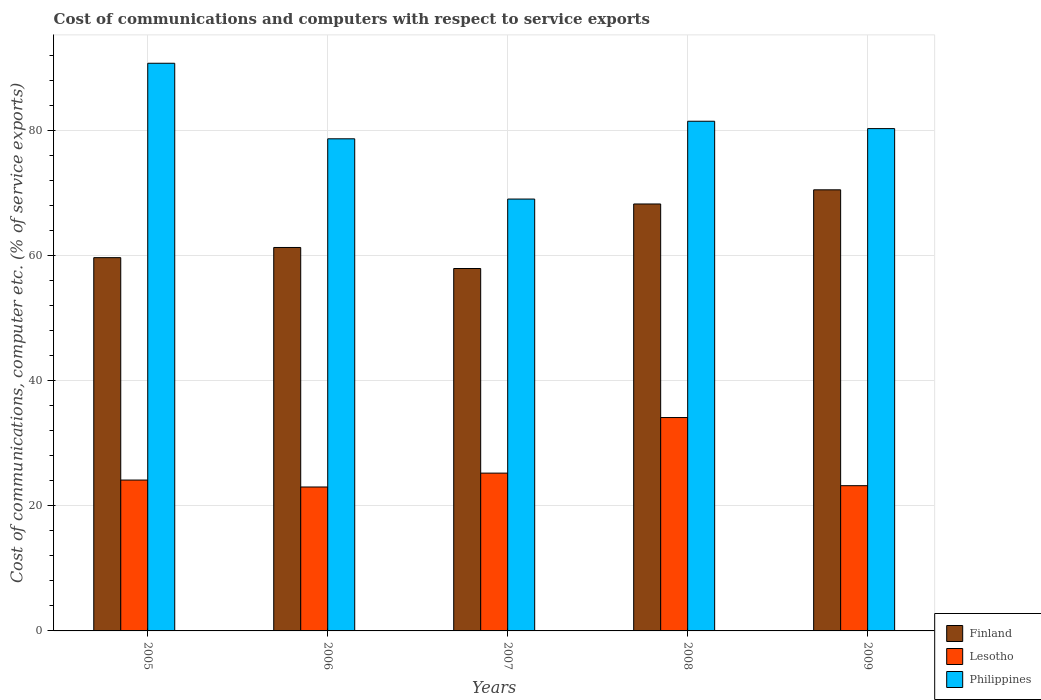Are the number of bars per tick equal to the number of legend labels?
Your answer should be very brief. Yes. What is the cost of communications and computers in Philippines in 2007?
Your answer should be compact. 69.06. Across all years, what is the maximum cost of communications and computers in Lesotho?
Your answer should be compact. 34.12. Across all years, what is the minimum cost of communications and computers in Lesotho?
Offer a very short reply. 23.02. In which year was the cost of communications and computers in Finland maximum?
Keep it short and to the point. 2009. What is the total cost of communications and computers in Lesotho in the graph?
Give a very brief answer. 129.72. What is the difference between the cost of communications and computers in Philippines in 2007 and that in 2008?
Provide a short and direct response. -12.44. What is the difference between the cost of communications and computers in Philippines in 2007 and the cost of communications and computers in Lesotho in 2005?
Ensure brevity in your answer.  44.94. What is the average cost of communications and computers in Lesotho per year?
Offer a terse response. 25.94. In the year 2008, what is the difference between the cost of communications and computers in Philippines and cost of communications and computers in Lesotho?
Provide a short and direct response. 47.38. In how many years, is the cost of communications and computers in Philippines greater than 20 %?
Provide a succinct answer. 5. What is the ratio of the cost of communications and computers in Finland in 2006 to that in 2008?
Give a very brief answer. 0.9. Is the difference between the cost of communications and computers in Philippines in 2008 and 2009 greater than the difference between the cost of communications and computers in Lesotho in 2008 and 2009?
Keep it short and to the point. No. What is the difference between the highest and the second highest cost of communications and computers in Finland?
Your response must be concise. 2.26. What is the difference between the highest and the lowest cost of communications and computers in Philippines?
Give a very brief answer. 21.72. Is the sum of the cost of communications and computers in Philippines in 2006 and 2008 greater than the maximum cost of communications and computers in Lesotho across all years?
Your answer should be compact. Yes. What does the 1st bar from the left in 2009 represents?
Offer a very short reply. Finland. What does the 2nd bar from the right in 2006 represents?
Give a very brief answer. Lesotho. How many years are there in the graph?
Make the answer very short. 5. What is the difference between two consecutive major ticks on the Y-axis?
Give a very brief answer. 20. Does the graph contain any zero values?
Your answer should be compact. No. Does the graph contain grids?
Ensure brevity in your answer.  Yes. How many legend labels are there?
Offer a terse response. 3. What is the title of the graph?
Offer a very short reply. Cost of communications and computers with respect to service exports. Does "Brazil" appear as one of the legend labels in the graph?
Your answer should be very brief. No. What is the label or title of the Y-axis?
Provide a succinct answer. Cost of communications, computer etc. (% of service exports). What is the Cost of communications, computer etc. (% of service exports) in Finland in 2005?
Offer a terse response. 59.69. What is the Cost of communications, computer etc. (% of service exports) in Lesotho in 2005?
Your response must be concise. 24.12. What is the Cost of communications, computer etc. (% of service exports) of Philippines in 2005?
Offer a very short reply. 90.78. What is the Cost of communications, computer etc. (% of service exports) of Finland in 2006?
Give a very brief answer. 61.32. What is the Cost of communications, computer etc. (% of service exports) in Lesotho in 2006?
Provide a succinct answer. 23.02. What is the Cost of communications, computer etc. (% of service exports) of Philippines in 2006?
Provide a short and direct response. 78.7. What is the Cost of communications, computer etc. (% of service exports) in Finland in 2007?
Make the answer very short. 57.95. What is the Cost of communications, computer etc. (% of service exports) in Lesotho in 2007?
Give a very brief answer. 25.24. What is the Cost of communications, computer etc. (% of service exports) of Philippines in 2007?
Your response must be concise. 69.06. What is the Cost of communications, computer etc. (% of service exports) of Finland in 2008?
Your answer should be very brief. 68.27. What is the Cost of communications, computer etc. (% of service exports) in Lesotho in 2008?
Give a very brief answer. 34.12. What is the Cost of communications, computer etc. (% of service exports) in Philippines in 2008?
Make the answer very short. 81.51. What is the Cost of communications, computer etc. (% of service exports) of Finland in 2009?
Your answer should be compact. 70.54. What is the Cost of communications, computer etc. (% of service exports) in Lesotho in 2009?
Ensure brevity in your answer.  23.23. What is the Cost of communications, computer etc. (% of service exports) in Philippines in 2009?
Provide a short and direct response. 80.33. Across all years, what is the maximum Cost of communications, computer etc. (% of service exports) of Finland?
Offer a very short reply. 70.54. Across all years, what is the maximum Cost of communications, computer etc. (% of service exports) in Lesotho?
Your answer should be very brief. 34.12. Across all years, what is the maximum Cost of communications, computer etc. (% of service exports) in Philippines?
Ensure brevity in your answer.  90.78. Across all years, what is the minimum Cost of communications, computer etc. (% of service exports) in Finland?
Your answer should be very brief. 57.95. Across all years, what is the minimum Cost of communications, computer etc. (% of service exports) of Lesotho?
Give a very brief answer. 23.02. Across all years, what is the minimum Cost of communications, computer etc. (% of service exports) of Philippines?
Provide a short and direct response. 69.06. What is the total Cost of communications, computer etc. (% of service exports) of Finland in the graph?
Your answer should be very brief. 317.78. What is the total Cost of communications, computer etc. (% of service exports) of Lesotho in the graph?
Provide a short and direct response. 129.72. What is the total Cost of communications, computer etc. (% of service exports) of Philippines in the graph?
Your answer should be very brief. 400.37. What is the difference between the Cost of communications, computer etc. (% of service exports) of Finland in 2005 and that in 2006?
Provide a short and direct response. -1.63. What is the difference between the Cost of communications, computer etc. (% of service exports) in Lesotho in 2005 and that in 2006?
Keep it short and to the point. 1.11. What is the difference between the Cost of communications, computer etc. (% of service exports) in Philippines in 2005 and that in 2006?
Give a very brief answer. 12.08. What is the difference between the Cost of communications, computer etc. (% of service exports) in Finland in 2005 and that in 2007?
Make the answer very short. 1.74. What is the difference between the Cost of communications, computer etc. (% of service exports) in Lesotho in 2005 and that in 2007?
Offer a very short reply. -1.11. What is the difference between the Cost of communications, computer etc. (% of service exports) of Philippines in 2005 and that in 2007?
Offer a very short reply. 21.71. What is the difference between the Cost of communications, computer etc. (% of service exports) in Finland in 2005 and that in 2008?
Offer a very short reply. -8.58. What is the difference between the Cost of communications, computer etc. (% of service exports) in Lesotho in 2005 and that in 2008?
Offer a terse response. -10. What is the difference between the Cost of communications, computer etc. (% of service exports) in Philippines in 2005 and that in 2008?
Offer a very short reply. 9.27. What is the difference between the Cost of communications, computer etc. (% of service exports) of Finland in 2005 and that in 2009?
Make the answer very short. -10.85. What is the difference between the Cost of communications, computer etc. (% of service exports) in Lesotho in 2005 and that in 2009?
Provide a succinct answer. 0.9. What is the difference between the Cost of communications, computer etc. (% of service exports) in Philippines in 2005 and that in 2009?
Your response must be concise. 10.45. What is the difference between the Cost of communications, computer etc. (% of service exports) in Finland in 2006 and that in 2007?
Offer a very short reply. 3.36. What is the difference between the Cost of communications, computer etc. (% of service exports) of Lesotho in 2006 and that in 2007?
Your response must be concise. -2.22. What is the difference between the Cost of communications, computer etc. (% of service exports) in Philippines in 2006 and that in 2007?
Give a very brief answer. 9.63. What is the difference between the Cost of communications, computer etc. (% of service exports) in Finland in 2006 and that in 2008?
Provide a short and direct response. -6.96. What is the difference between the Cost of communications, computer etc. (% of service exports) in Lesotho in 2006 and that in 2008?
Make the answer very short. -11.11. What is the difference between the Cost of communications, computer etc. (% of service exports) of Philippines in 2006 and that in 2008?
Keep it short and to the point. -2.81. What is the difference between the Cost of communications, computer etc. (% of service exports) in Finland in 2006 and that in 2009?
Your response must be concise. -9.22. What is the difference between the Cost of communications, computer etc. (% of service exports) of Lesotho in 2006 and that in 2009?
Provide a succinct answer. -0.21. What is the difference between the Cost of communications, computer etc. (% of service exports) in Philippines in 2006 and that in 2009?
Make the answer very short. -1.63. What is the difference between the Cost of communications, computer etc. (% of service exports) of Finland in 2007 and that in 2008?
Ensure brevity in your answer.  -10.32. What is the difference between the Cost of communications, computer etc. (% of service exports) of Lesotho in 2007 and that in 2008?
Give a very brief answer. -8.89. What is the difference between the Cost of communications, computer etc. (% of service exports) in Philippines in 2007 and that in 2008?
Your response must be concise. -12.44. What is the difference between the Cost of communications, computer etc. (% of service exports) in Finland in 2007 and that in 2009?
Your answer should be very brief. -12.58. What is the difference between the Cost of communications, computer etc. (% of service exports) of Lesotho in 2007 and that in 2009?
Offer a very short reply. 2.01. What is the difference between the Cost of communications, computer etc. (% of service exports) in Philippines in 2007 and that in 2009?
Your response must be concise. -11.27. What is the difference between the Cost of communications, computer etc. (% of service exports) of Finland in 2008 and that in 2009?
Your response must be concise. -2.26. What is the difference between the Cost of communications, computer etc. (% of service exports) in Lesotho in 2008 and that in 2009?
Make the answer very short. 10.9. What is the difference between the Cost of communications, computer etc. (% of service exports) of Philippines in 2008 and that in 2009?
Provide a succinct answer. 1.18. What is the difference between the Cost of communications, computer etc. (% of service exports) in Finland in 2005 and the Cost of communications, computer etc. (% of service exports) in Lesotho in 2006?
Your answer should be very brief. 36.68. What is the difference between the Cost of communications, computer etc. (% of service exports) of Finland in 2005 and the Cost of communications, computer etc. (% of service exports) of Philippines in 2006?
Offer a very short reply. -19. What is the difference between the Cost of communications, computer etc. (% of service exports) in Lesotho in 2005 and the Cost of communications, computer etc. (% of service exports) in Philippines in 2006?
Give a very brief answer. -54.57. What is the difference between the Cost of communications, computer etc. (% of service exports) in Finland in 2005 and the Cost of communications, computer etc. (% of service exports) in Lesotho in 2007?
Provide a short and direct response. 34.46. What is the difference between the Cost of communications, computer etc. (% of service exports) in Finland in 2005 and the Cost of communications, computer etc. (% of service exports) in Philippines in 2007?
Your answer should be very brief. -9.37. What is the difference between the Cost of communications, computer etc. (% of service exports) in Lesotho in 2005 and the Cost of communications, computer etc. (% of service exports) in Philippines in 2007?
Offer a terse response. -44.94. What is the difference between the Cost of communications, computer etc. (% of service exports) of Finland in 2005 and the Cost of communications, computer etc. (% of service exports) of Lesotho in 2008?
Ensure brevity in your answer.  25.57. What is the difference between the Cost of communications, computer etc. (% of service exports) of Finland in 2005 and the Cost of communications, computer etc. (% of service exports) of Philippines in 2008?
Provide a short and direct response. -21.81. What is the difference between the Cost of communications, computer etc. (% of service exports) of Lesotho in 2005 and the Cost of communications, computer etc. (% of service exports) of Philippines in 2008?
Keep it short and to the point. -57.38. What is the difference between the Cost of communications, computer etc. (% of service exports) of Finland in 2005 and the Cost of communications, computer etc. (% of service exports) of Lesotho in 2009?
Offer a very short reply. 36.47. What is the difference between the Cost of communications, computer etc. (% of service exports) of Finland in 2005 and the Cost of communications, computer etc. (% of service exports) of Philippines in 2009?
Make the answer very short. -20.64. What is the difference between the Cost of communications, computer etc. (% of service exports) in Lesotho in 2005 and the Cost of communications, computer etc. (% of service exports) in Philippines in 2009?
Provide a short and direct response. -56.2. What is the difference between the Cost of communications, computer etc. (% of service exports) of Finland in 2006 and the Cost of communications, computer etc. (% of service exports) of Lesotho in 2007?
Make the answer very short. 36.08. What is the difference between the Cost of communications, computer etc. (% of service exports) in Finland in 2006 and the Cost of communications, computer etc. (% of service exports) in Philippines in 2007?
Ensure brevity in your answer.  -7.74. What is the difference between the Cost of communications, computer etc. (% of service exports) of Lesotho in 2006 and the Cost of communications, computer etc. (% of service exports) of Philippines in 2007?
Offer a terse response. -46.05. What is the difference between the Cost of communications, computer etc. (% of service exports) of Finland in 2006 and the Cost of communications, computer etc. (% of service exports) of Lesotho in 2008?
Offer a very short reply. 27.2. What is the difference between the Cost of communications, computer etc. (% of service exports) of Finland in 2006 and the Cost of communications, computer etc. (% of service exports) of Philippines in 2008?
Your answer should be compact. -20.19. What is the difference between the Cost of communications, computer etc. (% of service exports) in Lesotho in 2006 and the Cost of communications, computer etc. (% of service exports) in Philippines in 2008?
Ensure brevity in your answer.  -58.49. What is the difference between the Cost of communications, computer etc. (% of service exports) of Finland in 2006 and the Cost of communications, computer etc. (% of service exports) of Lesotho in 2009?
Provide a short and direct response. 38.09. What is the difference between the Cost of communications, computer etc. (% of service exports) in Finland in 2006 and the Cost of communications, computer etc. (% of service exports) in Philippines in 2009?
Provide a succinct answer. -19.01. What is the difference between the Cost of communications, computer etc. (% of service exports) of Lesotho in 2006 and the Cost of communications, computer etc. (% of service exports) of Philippines in 2009?
Give a very brief answer. -57.31. What is the difference between the Cost of communications, computer etc. (% of service exports) of Finland in 2007 and the Cost of communications, computer etc. (% of service exports) of Lesotho in 2008?
Provide a succinct answer. 23.83. What is the difference between the Cost of communications, computer etc. (% of service exports) in Finland in 2007 and the Cost of communications, computer etc. (% of service exports) in Philippines in 2008?
Offer a terse response. -23.55. What is the difference between the Cost of communications, computer etc. (% of service exports) in Lesotho in 2007 and the Cost of communications, computer etc. (% of service exports) in Philippines in 2008?
Offer a very short reply. -56.27. What is the difference between the Cost of communications, computer etc. (% of service exports) in Finland in 2007 and the Cost of communications, computer etc. (% of service exports) in Lesotho in 2009?
Offer a very short reply. 34.73. What is the difference between the Cost of communications, computer etc. (% of service exports) in Finland in 2007 and the Cost of communications, computer etc. (% of service exports) in Philippines in 2009?
Offer a terse response. -22.37. What is the difference between the Cost of communications, computer etc. (% of service exports) of Lesotho in 2007 and the Cost of communications, computer etc. (% of service exports) of Philippines in 2009?
Provide a succinct answer. -55.09. What is the difference between the Cost of communications, computer etc. (% of service exports) in Finland in 2008 and the Cost of communications, computer etc. (% of service exports) in Lesotho in 2009?
Provide a short and direct response. 45.05. What is the difference between the Cost of communications, computer etc. (% of service exports) of Finland in 2008 and the Cost of communications, computer etc. (% of service exports) of Philippines in 2009?
Give a very brief answer. -12.05. What is the difference between the Cost of communications, computer etc. (% of service exports) of Lesotho in 2008 and the Cost of communications, computer etc. (% of service exports) of Philippines in 2009?
Provide a succinct answer. -46.21. What is the average Cost of communications, computer etc. (% of service exports) in Finland per year?
Make the answer very short. 63.56. What is the average Cost of communications, computer etc. (% of service exports) in Lesotho per year?
Provide a short and direct response. 25.94. What is the average Cost of communications, computer etc. (% of service exports) in Philippines per year?
Offer a very short reply. 80.07. In the year 2005, what is the difference between the Cost of communications, computer etc. (% of service exports) of Finland and Cost of communications, computer etc. (% of service exports) of Lesotho?
Ensure brevity in your answer.  35.57. In the year 2005, what is the difference between the Cost of communications, computer etc. (% of service exports) in Finland and Cost of communications, computer etc. (% of service exports) in Philippines?
Provide a succinct answer. -31.09. In the year 2005, what is the difference between the Cost of communications, computer etc. (% of service exports) of Lesotho and Cost of communications, computer etc. (% of service exports) of Philippines?
Provide a short and direct response. -66.65. In the year 2006, what is the difference between the Cost of communications, computer etc. (% of service exports) in Finland and Cost of communications, computer etc. (% of service exports) in Lesotho?
Ensure brevity in your answer.  38.3. In the year 2006, what is the difference between the Cost of communications, computer etc. (% of service exports) of Finland and Cost of communications, computer etc. (% of service exports) of Philippines?
Offer a terse response. -17.38. In the year 2006, what is the difference between the Cost of communications, computer etc. (% of service exports) in Lesotho and Cost of communications, computer etc. (% of service exports) in Philippines?
Your answer should be compact. -55.68. In the year 2007, what is the difference between the Cost of communications, computer etc. (% of service exports) of Finland and Cost of communications, computer etc. (% of service exports) of Lesotho?
Offer a very short reply. 32.72. In the year 2007, what is the difference between the Cost of communications, computer etc. (% of service exports) in Finland and Cost of communications, computer etc. (% of service exports) in Philippines?
Offer a terse response. -11.11. In the year 2007, what is the difference between the Cost of communications, computer etc. (% of service exports) of Lesotho and Cost of communications, computer etc. (% of service exports) of Philippines?
Offer a terse response. -43.83. In the year 2008, what is the difference between the Cost of communications, computer etc. (% of service exports) of Finland and Cost of communications, computer etc. (% of service exports) of Lesotho?
Make the answer very short. 34.15. In the year 2008, what is the difference between the Cost of communications, computer etc. (% of service exports) of Finland and Cost of communications, computer etc. (% of service exports) of Philippines?
Ensure brevity in your answer.  -13.23. In the year 2008, what is the difference between the Cost of communications, computer etc. (% of service exports) of Lesotho and Cost of communications, computer etc. (% of service exports) of Philippines?
Your response must be concise. -47.38. In the year 2009, what is the difference between the Cost of communications, computer etc. (% of service exports) in Finland and Cost of communications, computer etc. (% of service exports) in Lesotho?
Offer a very short reply. 47.31. In the year 2009, what is the difference between the Cost of communications, computer etc. (% of service exports) of Finland and Cost of communications, computer etc. (% of service exports) of Philippines?
Keep it short and to the point. -9.79. In the year 2009, what is the difference between the Cost of communications, computer etc. (% of service exports) in Lesotho and Cost of communications, computer etc. (% of service exports) in Philippines?
Provide a short and direct response. -57.1. What is the ratio of the Cost of communications, computer etc. (% of service exports) in Finland in 2005 to that in 2006?
Your answer should be very brief. 0.97. What is the ratio of the Cost of communications, computer etc. (% of service exports) of Lesotho in 2005 to that in 2006?
Ensure brevity in your answer.  1.05. What is the ratio of the Cost of communications, computer etc. (% of service exports) in Philippines in 2005 to that in 2006?
Make the answer very short. 1.15. What is the ratio of the Cost of communications, computer etc. (% of service exports) of Lesotho in 2005 to that in 2007?
Offer a very short reply. 0.96. What is the ratio of the Cost of communications, computer etc. (% of service exports) of Philippines in 2005 to that in 2007?
Keep it short and to the point. 1.31. What is the ratio of the Cost of communications, computer etc. (% of service exports) in Finland in 2005 to that in 2008?
Your response must be concise. 0.87. What is the ratio of the Cost of communications, computer etc. (% of service exports) of Lesotho in 2005 to that in 2008?
Offer a very short reply. 0.71. What is the ratio of the Cost of communications, computer etc. (% of service exports) in Philippines in 2005 to that in 2008?
Your answer should be very brief. 1.11. What is the ratio of the Cost of communications, computer etc. (% of service exports) of Finland in 2005 to that in 2009?
Provide a succinct answer. 0.85. What is the ratio of the Cost of communications, computer etc. (% of service exports) in Lesotho in 2005 to that in 2009?
Give a very brief answer. 1.04. What is the ratio of the Cost of communications, computer etc. (% of service exports) of Philippines in 2005 to that in 2009?
Offer a terse response. 1.13. What is the ratio of the Cost of communications, computer etc. (% of service exports) of Finland in 2006 to that in 2007?
Make the answer very short. 1.06. What is the ratio of the Cost of communications, computer etc. (% of service exports) in Lesotho in 2006 to that in 2007?
Keep it short and to the point. 0.91. What is the ratio of the Cost of communications, computer etc. (% of service exports) in Philippines in 2006 to that in 2007?
Offer a very short reply. 1.14. What is the ratio of the Cost of communications, computer etc. (% of service exports) in Finland in 2006 to that in 2008?
Offer a terse response. 0.9. What is the ratio of the Cost of communications, computer etc. (% of service exports) in Lesotho in 2006 to that in 2008?
Make the answer very short. 0.67. What is the ratio of the Cost of communications, computer etc. (% of service exports) of Philippines in 2006 to that in 2008?
Offer a very short reply. 0.97. What is the ratio of the Cost of communications, computer etc. (% of service exports) of Finland in 2006 to that in 2009?
Offer a terse response. 0.87. What is the ratio of the Cost of communications, computer etc. (% of service exports) in Lesotho in 2006 to that in 2009?
Your answer should be very brief. 0.99. What is the ratio of the Cost of communications, computer etc. (% of service exports) of Philippines in 2006 to that in 2009?
Give a very brief answer. 0.98. What is the ratio of the Cost of communications, computer etc. (% of service exports) in Finland in 2007 to that in 2008?
Provide a succinct answer. 0.85. What is the ratio of the Cost of communications, computer etc. (% of service exports) in Lesotho in 2007 to that in 2008?
Make the answer very short. 0.74. What is the ratio of the Cost of communications, computer etc. (% of service exports) of Philippines in 2007 to that in 2008?
Make the answer very short. 0.85. What is the ratio of the Cost of communications, computer etc. (% of service exports) in Finland in 2007 to that in 2009?
Make the answer very short. 0.82. What is the ratio of the Cost of communications, computer etc. (% of service exports) of Lesotho in 2007 to that in 2009?
Make the answer very short. 1.09. What is the ratio of the Cost of communications, computer etc. (% of service exports) of Philippines in 2007 to that in 2009?
Your answer should be compact. 0.86. What is the ratio of the Cost of communications, computer etc. (% of service exports) in Finland in 2008 to that in 2009?
Give a very brief answer. 0.97. What is the ratio of the Cost of communications, computer etc. (% of service exports) of Lesotho in 2008 to that in 2009?
Your response must be concise. 1.47. What is the ratio of the Cost of communications, computer etc. (% of service exports) in Philippines in 2008 to that in 2009?
Ensure brevity in your answer.  1.01. What is the difference between the highest and the second highest Cost of communications, computer etc. (% of service exports) in Finland?
Your answer should be very brief. 2.26. What is the difference between the highest and the second highest Cost of communications, computer etc. (% of service exports) of Lesotho?
Provide a short and direct response. 8.89. What is the difference between the highest and the second highest Cost of communications, computer etc. (% of service exports) of Philippines?
Offer a terse response. 9.27. What is the difference between the highest and the lowest Cost of communications, computer etc. (% of service exports) in Finland?
Your answer should be compact. 12.58. What is the difference between the highest and the lowest Cost of communications, computer etc. (% of service exports) in Lesotho?
Give a very brief answer. 11.11. What is the difference between the highest and the lowest Cost of communications, computer etc. (% of service exports) of Philippines?
Provide a succinct answer. 21.71. 